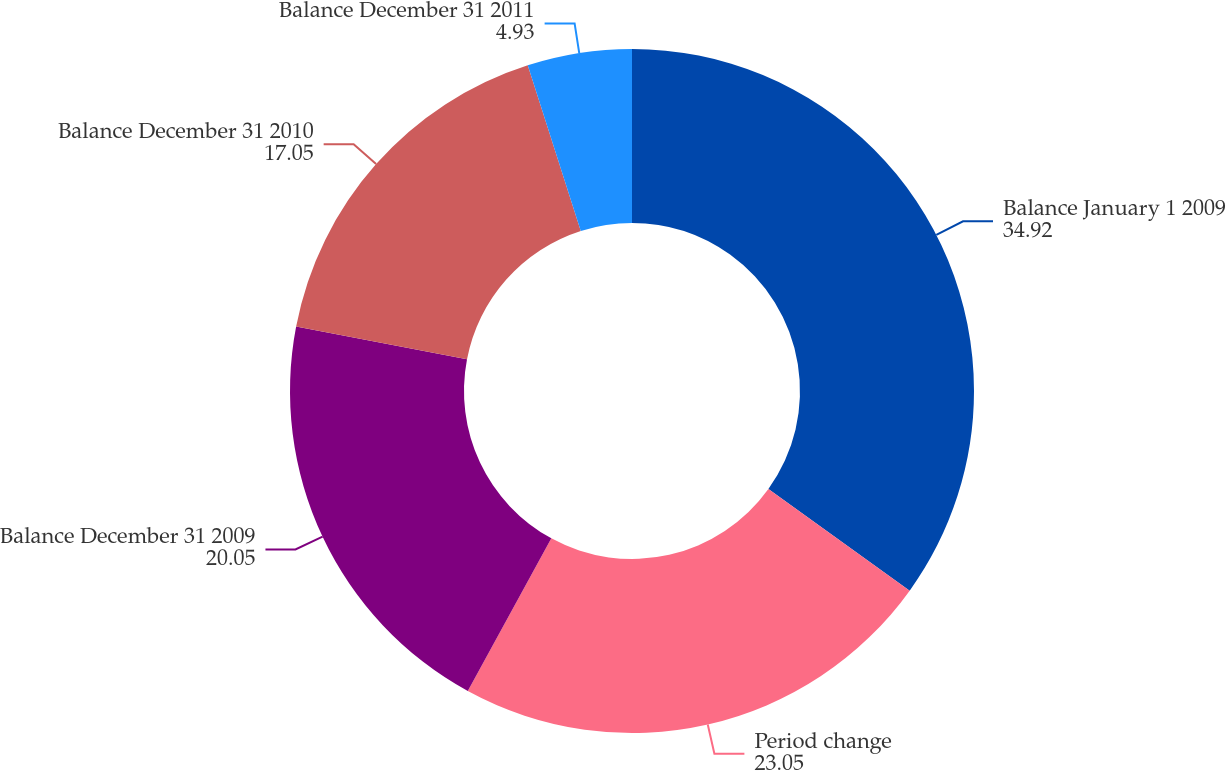<chart> <loc_0><loc_0><loc_500><loc_500><pie_chart><fcel>Balance January 1 2009<fcel>Period change<fcel>Balance December 31 2009<fcel>Balance December 31 2010<fcel>Balance December 31 2011<nl><fcel>34.92%<fcel>23.05%<fcel>20.05%<fcel>17.05%<fcel>4.93%<nl></chart> 